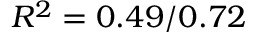Convert formula to latex. <formula><loc_0><loc_0><loc_500><loc_500>R ^ { 2 } = 0 . 4 9 / 0 . 7 2</formula> 